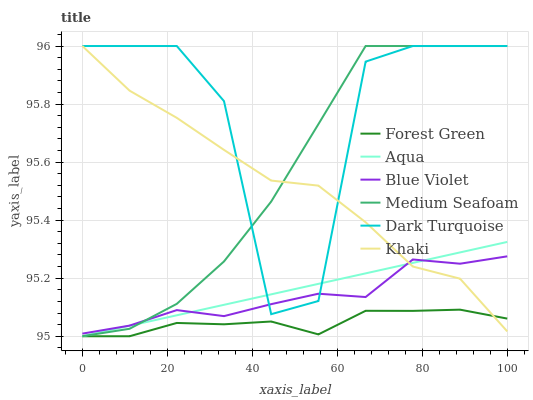Does Forest Green have the minimum area under the curve?
Answer yes or no. Yes. Does Dark Turquoise have the maximum area under the curve?
Answer yes or no. Yes. Does Aqua have the minimum area under the curve?
Answer yes or no. No. Does Aqua have the maximum area under the curve?
Answer yes or no. No. Is Aqua the smoothest?
Answer yes or no. Yes. Is Dark Turquoise the roughest?
Answer yes or no. Yes. Is Dark Turquoise the smoothest?
Answer yes or no. No. Is Aqua the roughest?
Answer yes or no. No. Does Aqua have the lowest value?
Answer yes or no. Yes. Does Dark Turquoise have the lowest value?
Answer yes or no. No. Does Medium Seafoam have the highest value?
Answer yes or no. Yes. Does Aqua have the highest value?
Answer yes or no. No. Is Forest Green less than Blue Violet?
Answer yes or no. Yes. Is Medium Seafoam greater than Forest Green?
Answer yes or no. Yes. Does Aqua intersect Khaki?
Answer yes or no. Yes. Is Aqua less than Khaki?
Answer yes or no. No. Is Aqua greater than Khaki?
Answer yes or no. No. Does Forest Green intersect Blue Violet?
Answer yes or no. No. 